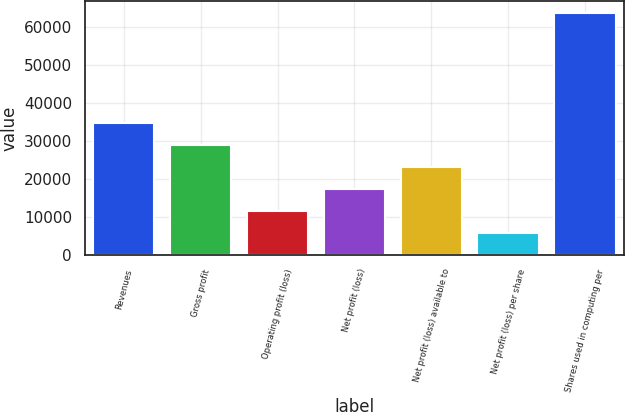Convert chart to OTSL. <chart><loc_0><loc_0><loc_500><loc_500><bar_chart><fcel>Revenues<fcel>Gross profit<fcel>Operating profit (loss)<fcel>Net profit (loss)<fcel>Net profit (loss) available to<fcel>Net profit (loss) per share<fcel>Shares used in computing per<nl><fcel>34768.8<fcel>28974<fcel>11589.6<fcel>17384.4<fcel>23179.2<fcel>5794.84<fcel>63742.8<nl></chart> 